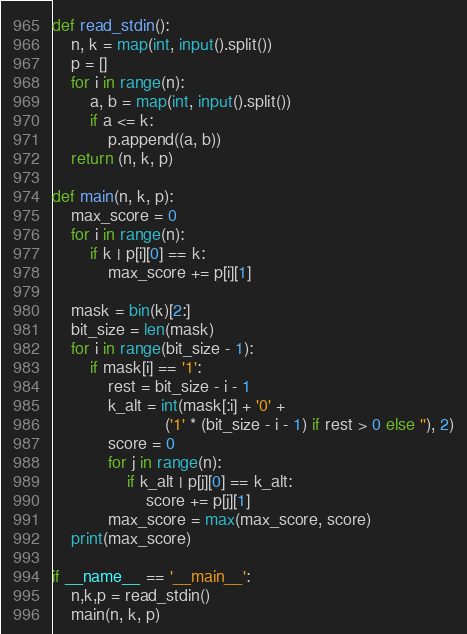<code> <loc_0><loc_0><loc_500><loc_500><_Python_>def read_stdin():
    n, k = map(int, input().split())
    p = []
    for i in range(n):
        a, b = map(int, input().split())
        if a <= k:
            p.append((a, b))
    return (n, k, p)

def main(n, k, p):
    max_score = 0
    for i in range(n):
        if k | p[i][0] == k:
            max_score += p[i][1]

    mask = bin(k)[2:]
    bit_size = len(mask)
    for i in range(bit_size - 1):
        if mask[i] == '1':
            rest = bit_size - i - 1
            k_alt = int(mask[:i] + '0' +
                        ('1' * (bit_size - i - 1) if rest > 0 else ''), 2)
            score = 0
            for j in range(n):
                if k_alt | p[j][0] == k_alt:
                    score += p[j][1]
            max_score = max(max_score, score)
    print(max_score)

if __name__ == '__main__':
    n,k,p = read_stdin()
    main(n, k, p)
</code> 